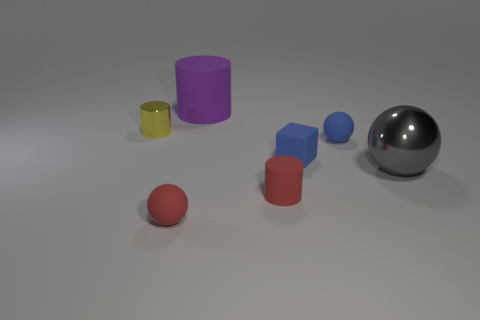How many tiny matte spheres have the same color as the matte block?
Make the answer very short. 1. What number of objects are either rubber objects behind the small yellow thing or rubber cylinders that are behind the gray thing?
Provide a succinct answer. 1. Is the number of yellow metal cylinders greater than the number of rubber spheres?
Provide a short and direct response. No. The large object in front of the big purple cylinder is what color?
Your answer should be compact. Gray. Does the large gray object have the same shape as the yellow thing?
Your answer should be very brief. No. The cylinder that is both right of the tiny yellow metal thing and behind the gray metallic sphere is what color?
Ensure brevity in your answer.  Purple. There is a object that is to the left of the small red matte ball; is it the same size as the red matte object that is to the right of the big matte cylinder?
Keep it short and to the point. Yes. What number of things are either rubber spheres that are behind the tiny red matte ball or small blue rubber spheres?
Keep it short and to the point. 1. What is the purple thing made of?
Your response must be concise. Rubber. Do the blue cube and the purple object have the same size?
Your answer should be very brief. No. 